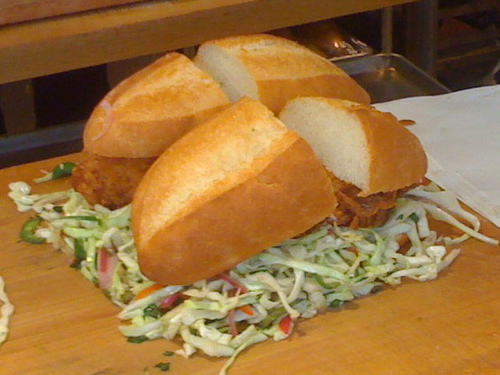How many boys are in this picture? There are no boys in this picture; it is an image of a sandwich with a side of coleslaw. 